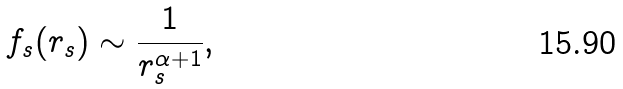<formula> <loc_0><loc_0><loc_500><loc_500>f _ { s } ( r _ { s } ) \sim \frac { 1 } { r _ { s } ^ { \alpha + 1 } } ,</formula> 